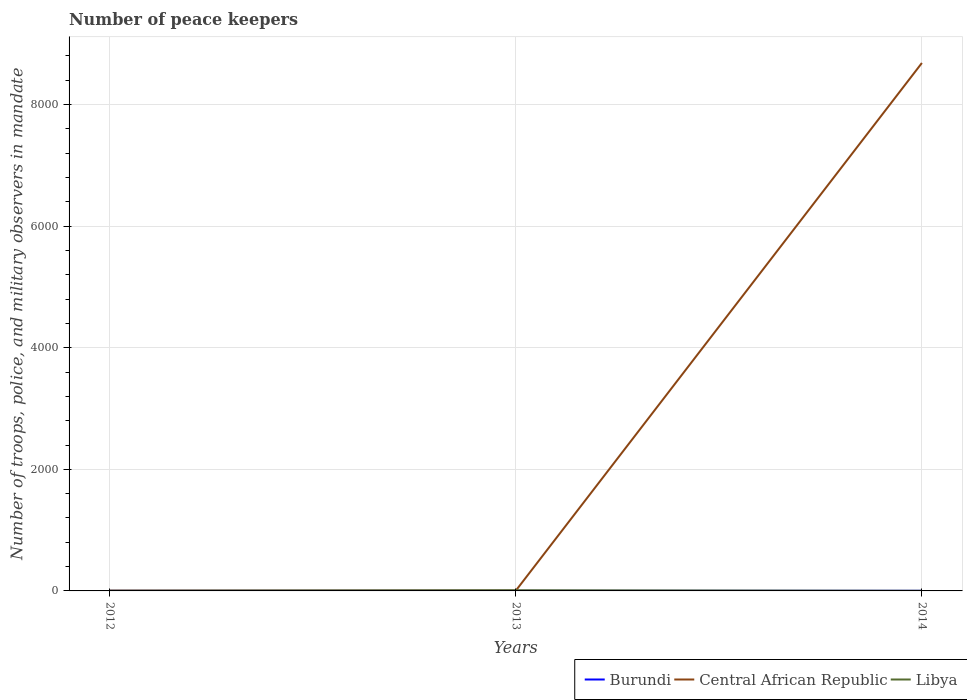Does the line corresponding to Central African Republic intersect with the line corresponding to Libya?
Provide a short and direct response. Yes. Is the number of lines equal to the number of legend labels?
Provide a short and direct response. Yes. In which year was the number of peace keepers in in Central African Republic maximum?
Make the answer very short. 2012. What is the total number of peace keepers in in Central African Republic in the graph?
Your answer should be compact. -8681. What is the difference between the highest and the second highest number of peace keepers in in Burundi?
Offer a very short reply. 0. What is the difference between the highest and the lowest number of peace keepers in in Libya?
Ensure brevity in your answer.  1. Is the number of peace keepers in in Central African Republic strictly greater than the number of peace keepers in in Burundi over the years?
Make the answer very short. No. How many lines are there?
Keep it short and to the point. 3. How many years are there in the graph?
Make the answer very short. 3. What is the difference between two consecutive major ticks on the Y-axis?
Make the answer very short. 2000. Does the graph contain grids?
Give a very brief answer. Yes. Where does the legend appear in the graph?
Ensure brevity in your answer.  Bottom right. How many legend labels are there?
Give a very brief answer. 3. What is the title of the graph?
Keep it short and to the point. Number of peace keepers. What is the label or title of the Y-axis?
Offer a terse response. Number of troops, police, and military observers in mandate. What is the Number of troops, police, and military observers in mandate in Burundi in 2013?
Your answer should be compact. 2. What is the Number of troops, police, and military observers in mandate in Central African Republic in 2013?
Provide a succinct answer. 4. What is the Number of troops, police, and military observers in mandate in Libya in 2013?
Give a very brief answer. 11. What is the Number of troops, police, and military observers in mandate in Burundi in 2014?
Your answer should be compact. 2. What is the Number of troops, police, and military observers in mandate of Central African Republic in 2014?
Your answer should be very brief. 8685. What is the Number of troops, police, and military observers in mandate of Libya in 2014?
Ensure brevity in your answer.  2. Across all years, what is the maximum Number of troops, police, and military observers in mandate of Central African Republic?
Keep it short and to the point. 8685. Across all years, what is the maximum Number of troops, police, and military observers in mandate of Libya?
Give a very brief answer. 11. Across all years, what is the minimum Number of troops, police, and military observers in mandate in Burundi?
Provide a succinct answer. 2. Across all years, what is the minimum Number of troops, police, and military observers in mandate in Central African Republic?
Offer a very short reply. 4. Across all years, what is the minimum Number of troops, police, and military observers in mandate in Libya?
Offer a very short reply. 2. What is the total Number of troops, police, and military observers in mandate in Central African Republic in the graph?
Offer a terse response. 8693. What is the total Number of troops, police, and military observers in mandate of Libya in the graph?
Offer a terse response. 15. What is the difference between the Number of troops, police, and military observers in mandate of Burundi in 2012 and that in 2014?
Ensure brevity in your answer.  0. What is the difference between the Number of troops, police, and military observers in mandate in Central African Republic in 2012 and that in 2014?
Your answer should be compact. -8681. What is the difference between the Number of troops, police, and military observers in mandate in Libya in 2012 and that in 2014?
Give a very brief answer. 0. What is the difference between the Number of troops, police, and military observers in mandate of Central African Republic in 2013 and that in 2014?
Give a very brief answer. -8681. What is the difference between the Number of troops, police, and military observers in mandate in Burundi in 2012 and the Number of troops, police, and military observers in mandate in Central African Republic in 2013?
Your answer should be compact. -2. What is the difference between the Number of troops, police, and military observers in mandate of Burundi in 2012 and the Number of troops, police, and military observers in mandate of Central African Republic in 2014?
Ensure brevity in your answer.  -8683. What is the difference between the Number of troops, police, and military observers in mandate in Burundi in 2012 and the Number of troops, police, and military observers in mandate in Libya in 2014?
Offer a terse response. 0. What is the difference between the Number of troops, police, and military observers in mandate in Burundi in 2013 and the Number of troops, police, and military observers in mandate in Central African Republic in 2014?
Make the answer very short. -8683. What is the average Number of troops, police, and military observers in mandate of Central African Republic per year?
Your response must be concise. 2897.67. What is the average Number of troops, police, and military observers in mandate in Libya per year?
Offer a very short reply. 5. In the year 2012, what is the difference between the Number of troops, police, and military observers in mandate of Burundi and Number of troops, police, and military observers in mandate of Central African Republic?
Your answer should be very brief. -2. In the year 2013, what is the difference between the Number of troops, police, and military observers in mandate of Burundi and Number of troops, police, and military observers in mandate of Libya?
Your answer should be compact. -9. In the year 2014, what is the difference between the Number of troops, police, and military observers in mandate in Burundi and Number of troops, police, and military observers in mandate in Central African Republic?
Your answer should be very brief. -8683. In the year 2014, what is the difference between the Number of troops, police, and military observers in mandate of Burundi and Number of troops, police, and military observers in mandate of Libya?
Keep it short and to the point. 0. In the year 2014, what is the difference between the Number of troops, police, and military observers in mandate in Central African Republic and Number of troops, police, and military observers in mandate in Libya?
Keep it short and to the point. 8683. What is the ratio of the Number of troops, police, and military observers in mandate of Burundi in 2012 to that in 2013?
Your answer should be very brief. 1. What is the ratio of the Number of troops, police, and military observers in mandate in Libya in 2012 to that in 2013?
Ensure brevity in your answer.  0.18. What is the ratio of the Number of troops, police, and military observers in mandate of Central African Republic in 2012 to that in 2014?
Your answer should be compact. 0. What is the ratio of the Number of troops, police, and military observers in mandate of Libya in 2012 to that in 2014?
Give a very brief answer. 1. What is the ratio of the Number of troops, police, and military observers in mandate of Central African Republic in 2013 to that in 2014?
Provide a succinct answer. 0. What is the difference between the highest and the second highest Number of troops, police, and military observers in mandate in Central African Republic?
Offer a very short reply. 8681. What is the difference between the highest and the lowest Number of troops, police, and military observers in mandate of Central African Republic?
Ensure brevity in your answer.  8681. 